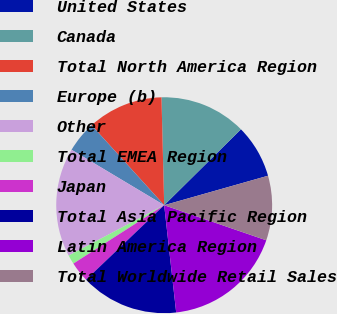Convert chart. <chart><loc_0><loc_0><loc_500><loc_500><pie_chart><fcel>United States<fcel>Canada<fcel>Total North America Region<fcel>Europe (b)<fcel>Other<fcel>Total EMEA Region<fcel>Japan<fcel>Total Asia Pacific Region<fcel>Latin America Region<fcel>Total Worldwide Retail Sales<nl><fcel>8.01%<fcel>12.99%<fcel>11.33%<fcel>4.69%<fcel>16.31%<fcel>1.37%<fcel>3.03%<fcel>14.65%<fcel>17.96%<fcel>9.67%<nl></chart> 